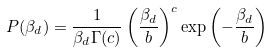<formula> <loc_0><loc_0><loc_500><loc_500>P ( \beta _ { d } ) = \frac { 1 } { \beta _ { d } \Gamma ( c ) } \left ( \frac { \beta _ { d } } { b } \right ) ^ { c } \exp \left ( - \frac { \beta _ { d } } { b } \right )</formula> 